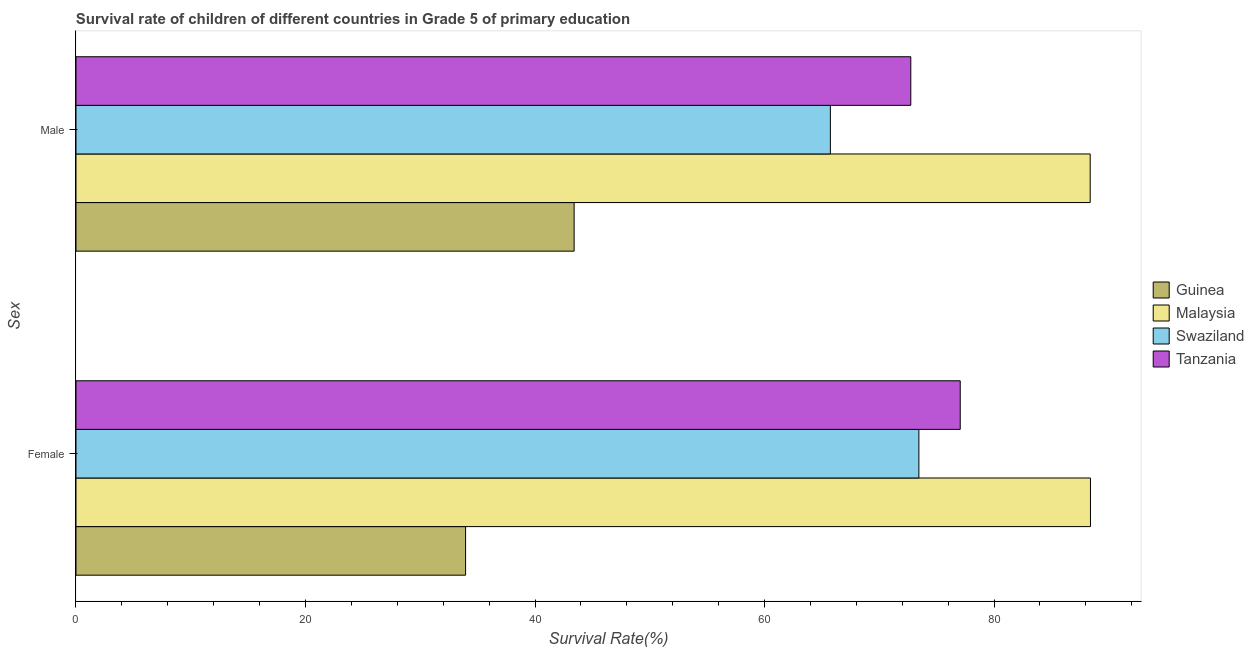How many different coloured bars are there?
Your answer should be compact. 4. How many groups of bars are there?
Provide a succinct answer. 2. How many bars are there on the 1st tick from the bottom?
Ensure brevity in your answer.  4. What is the label of the 2nd group of bars from the top?
Ensure brevity in your answer.  Female. What is the survival rate of male students in primary education in Malaysia?
Provide a succinct answer. 88.38. Across all countries, what is the maximum survival rate of male students in primary education?
Keep it short and to the point. 88.38. Across all countries, what is the minimum survival rate of male students in primary education?
Ensure brevity in your answer.  43.41. In which country was the survival rate of female students in primary education maximum?
Offer a terse response. Malaysia. In which country was the survival rate of female students in primary education minimum?
Your answer should be compact. Guinea. What is the total survival rate of male students in primary education in the graph?
Your answer should be very brief. 270.28. What is the difference between the survival rate of male students in primary education in Guinea and that in Malaysia?
Ensure brevity in your answer.  -44.97. What is the difference between the survival rate of female students in primary education in Guinea and the survival rate of male students in primary education in Tanzania?
Offer a terse response. -38.8. What is the average survival rate of female students in primary education per country?
Give a very brief answer. 68.22. What is the difference between the survival rate of male students in primary education and survival rate of female students in primary education in Malaysia?
Keep it short and to the point. -0.02. What is the ratio of the survival rate of male students in primary education in Malaysia to that in Swaziland?
Provide a succinct answer. 1.34. Is the survival rate of female students in primary education in Malaysia less than that in Swaziland?
Your answer should be compact. No. What does the 1st bar from the top in Female represents?
Your answer should be compact. Tanzania. What does the 3rd bar from the bottom in Male represents?
Ensure brevity in your answer.  Swaziland. How many bars are there?
Provide a succinct answer. 8. Are all the bars in the graph horizontal?
Your answer should be very brief. Yes. Does the graph contain any zero values?
Offer a terse response. No. Does the graph contain grids?
Your answer should be compact. No. Where does the legend appear in the graph?
Provide a short and direct response. Center right. How many legend labels are there?
Your answer should be compact. 4. What is the title of the graph?
Ensure brevity in your answer.  Survival rate of children of different countries in Grade 5 of primary education. Does "Trinidad and Tobago" appear as one of the legend labels in the graph?
Your answer should be very brief. No. What is the label or title of the X-axis?
Your answer should be very brief. Survival Rate(%). What is the label or title of the Y-axis?
Ensure brevity in your answer.  Sex. What is the Survival Rate(%) of Guinea in Female?
Offer a very short reply. 33.95. What is the Survival Rate(%) in Malaysia in Female?
Your answer should be very brief. 88.41. What is the Survival Rate(%) of Swaziland in Female?
Give a very brief answer. 73.45. What is the Survival Rate(%) of Tanzania in Female?
Your answer should be compact. 77.06. What is the Survival Rate(%) in Guinea in Male?
Keep it short and to the point. 43.41. What is the Survival Rate(%) of Malaysia in Male?
Ensure brevity in your answer.  88.38. What is the Survival Rate(%) in Swaziland in Male?
Your answer should be compact. 65.74. What is the Survival Rate(%) of Tanzania in Male?
Make the answer very short. 72.75. Across all Sex, what is the maximum Survival Rate(%) of Guinea?
Provide a succinct answer. 43.41. Across all Sex, what is the maximum Survival Rate(%) of Malaysia?
Provide a succinct answer. 88.41. Across all Sex, what is the maximum Survival Rate(%) of Swaziland?
Offer a very short reply. 73.45. Across all Sex, what is the maximum Survival Rate(%) in Tanzania?
Offer a terse response. 77.06. Across all Sex, what is the minimum Survival Rate(%) in Guinea?
Give a very brief answer. 33.95. Across all Sex, what is the minimum Survival Rate(%) in Malaysia?
Ensure brevity in your answer.  88.38. Across all Sex, what is the minimum Survival Rate(%) in Swaziland?
Your answer should be very brief. 65.74. Across all Sex, what is the minimum Survival Rate(%) in Tanzania?
Provide a short and direct response. 72.75. What is the total Survival Rate(%) in Guinea in the graph?
Offer a terse response. 77.36. What is the total Survival Rate(%) in Malaysia in the graph?
Keep it short and to the point. 176.79. What is the total Survival Rate(%) of Swaziland in the graph?
Give a very brief answer. 139.19. What is the total Survival Rate(%) of Tanzania in the graph?
Ensure brevity in your answer.  149.81. What is the difference between the Survival Rate(%) of Guinea in Female and that in Male?
Your response must be concise. -9.46. What is the difference between the Survival Rate(%) in Malaysia in Female and that in Male?
Ensure brevity in your answer.  0.02. What is the difference between the Survival Rate(%) in Swaziland in Female and that in Male?
Keep it short and to the point. 7.71. What is the difference between the Survival Rate(%) of Tanzania in Female and that in Male?
Make the answer very short. 4.31. What is the difference between the Survival Rate(%) in Guinea in Female and the Survival Rate(%) in Malaysia in Male?
Your answer should be compact. -54.43. What is the difference between the Survival Rate(%) of Guinea in Female and the Survival Rate(%) of Swaziland in Male?
Give a very brief answer. -31.79. What is the difference between the Survival Rate(%) of Guinea in Female and the Survival Rate(%) of Tanzania in Male?
Your response must be concise. -38.8. What is the difference between the Survival Rate(%) of Malaysia in Female and the Survival Rate(%) of Swaziland in Male?
Keep it short and to the point. 22.67. What is the difference between the Survival Rate(%) in Malaysia in Female and the Survival Rate(%) in Tanzania in Male?
Offer a very short reply. 15.66. What is the difference between the Survival Rate(%) in Swaziland in Female and the Survival Rate(%) in Tanzania in Male?
Your answer should be compact. 0.7. What is the average Survival Rate(%) of Guinea per Sex?
Your answer should be very brief. 38.68. What is the average Survival Rate(%) of Malaysia per Sex?
Keep it short and to the point. 88.39. What is the average Survival Rate(%) of Swaziland per Sex?
Your response must be concise. 69.6. What is the average Survival Rate(%) of Tanzania per Sex?
Offer a very short reply. 74.9. What is the difference between the Survival Rate(%) of Guinea and Survival Rate(%) of Malaysia in Female?
Keep it short and to the point. -54.45. What is the difference between the Survival Rate(%) in Guinea and Survival Rate(%) in Swaziland in Female?
Provide a succinct answer. -39.5. What is the difference between the Survival Rate(%) of Guinea and Survival Rate(%) of Tanzania in Female?
Your answer should be very brief. -43.11. What is the difference between the Survival Rate(%) in Malaysia and Survival Rate(%) in Swaziland in Female?
Provide a succinct answer. 14.95. What is the difference between the Survival Rate(%) of Malaysia and Survival Rate(%) of Tanzania in Female?
Your answer should be compact. 11.35. What is the difference between the Survival Rate(%) in Swaziland and Survival Rate(%) in Tanzania in Female?
Your answer should be very brief. -3.6. What is the difference between the Survival Rate(%) in Guinea and Survival Rate(%) in Malaysia in Male?
Your answer should be compact. -44.97. What is the difference between the Survival Rate(%) in Guinea and Survival Rate(%) in Swaziland in Male?
Ensure brevity in your answer.  -22.33. What is the difference between the Survival Rate(%) of Guinea and Survival Rate(%) of Tanzania in Male?
Keep it short and to the point. -29.34. What is the difference between the Survival Rate(%) of Malaysia and Survival Rate(%) of Swaziland in Male?
Provide a short and direct response. 22.64. What is the difference between the Survival Rate(%) of Malaysia and Survival Rate(%) of Tanzania in Male?
Keep it short and to the point. 15.63. What is the difference between the Survival Rate(%) in Swaziland and Survival Rate(%) in Tanzania in Male?
Make the answer very short. -7.01. What is the ratio of the Survival Rate(%) of Guinea in Female to that in Male?
Your answer should be compact. 0.78. What is the ratio of the Survival Rate(%) of Malaysia in Female to that in Male?
Your response must be concise. 1. What is the ratio of the Survival Rate(%) in Swaziland in Female to that in Male?
Keep it short and to the point. 1.12. What is the ratio of the Survival Rate(%) of Tanzania in Female to that in Male?
Ensure brevity in your answer.  1.06. What is the difference between the highest and the second highest Survival Rate(%) of Guinea?
Give a very brief answer. 9.46. What is the difference between the highest and the second highest Survival Rate(%) of Malaysia?
Your response must be concise. 0.02. What is the difference between the highest and the second highest Survival Rate(%) in Swaziland?
Keep it short and to the point. 7.71. What is the difference between the highest and the second highest Survival Rate(%) in Tanzania?
Make the answer very short. 4.31. What is the difference between the highest and the lowest Survival Rate(%) of Guinea?
Provide a short and direct response. 9.46. What is the difference between the highest and the lowest Survival Rate(%) in Malaysia?
Keep it short and to the point. 0.02. What is the difference between the highest and the lowest Survival Rate(%) of Swaziland?
Give a very brief answer. 7.71. What is the difference between the highest and the lowest Survival Rate(%) of Tanzania?
Your response must be concise. 4.31. 